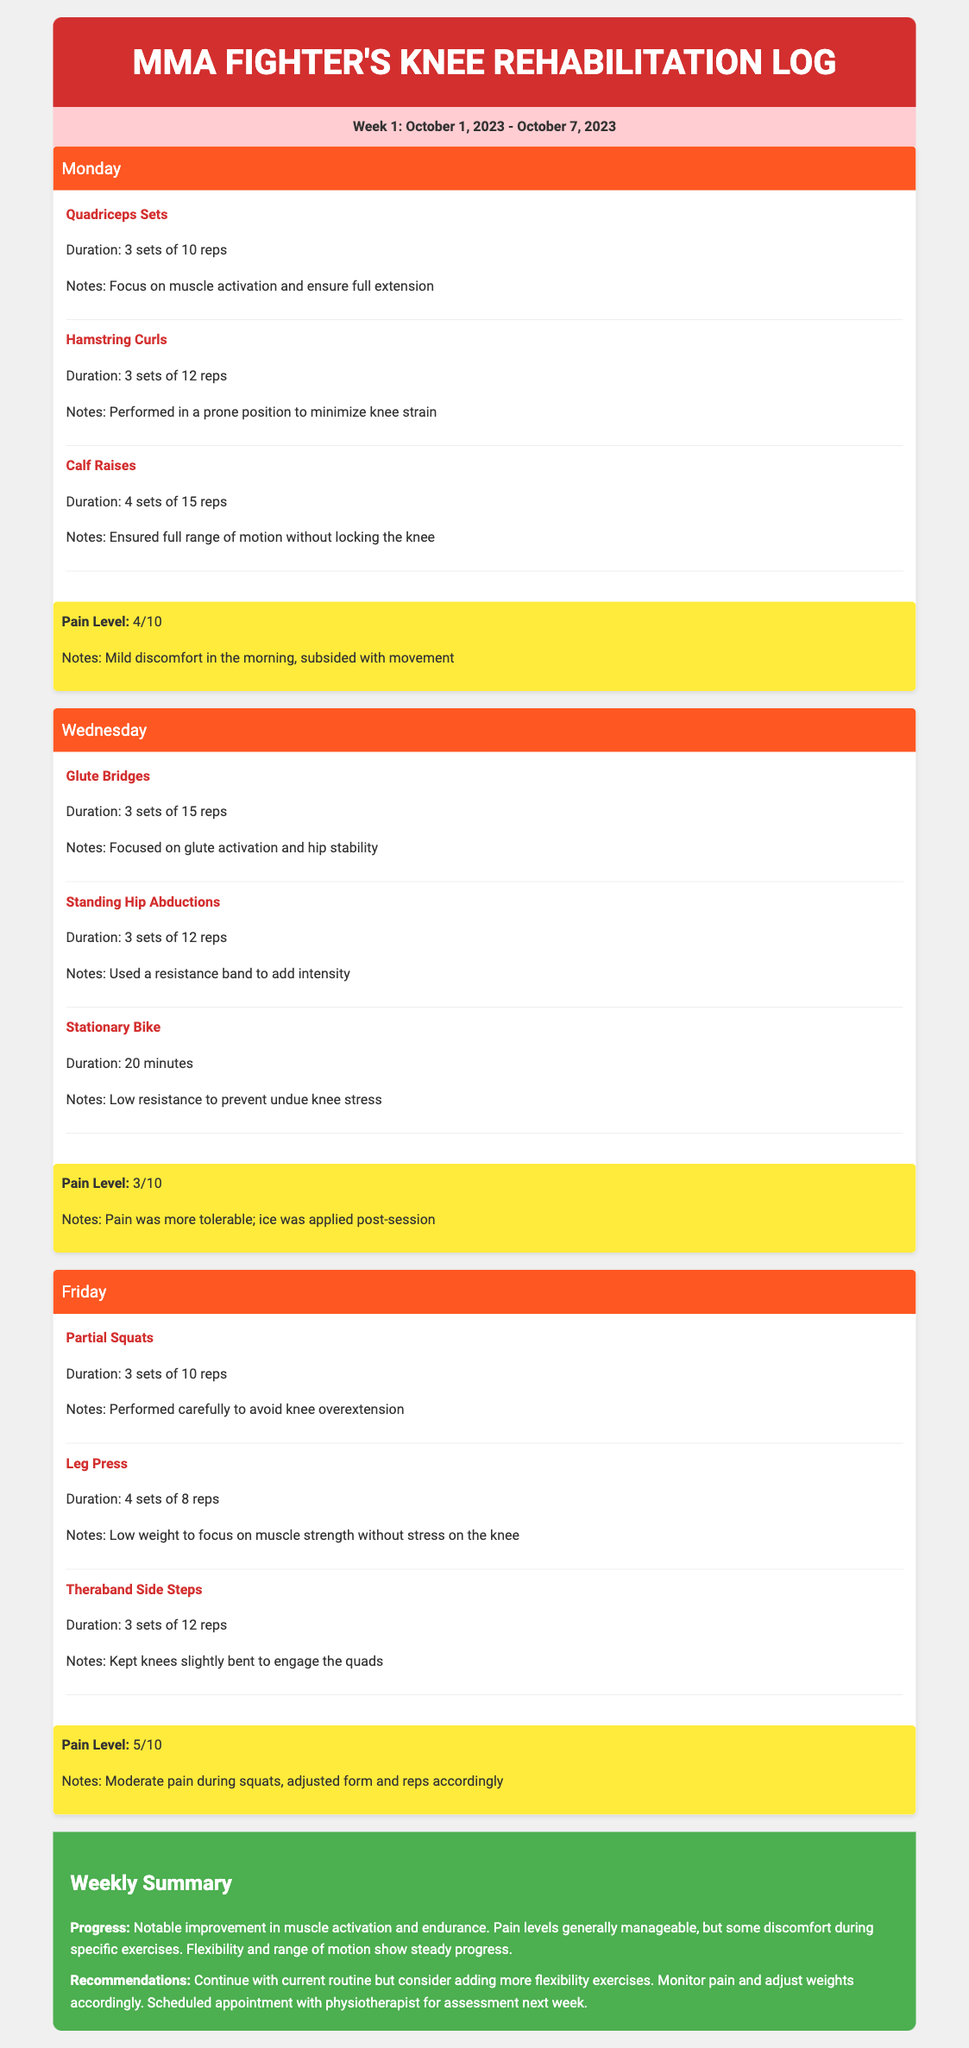What week does the log cover? The week covered in the log is from October 1, 2023, to October 7, 2023.
Answer: Week 1: October 1, 2023 - October 7, 2023 What exercise was performed on Monday? The exercises performed on Monday include Quadriceps Sets, Hamstring Curls, and Calf Raises.
Answer: Quadriceps Sets, Hamstring Curls, Calf Raises What was the pain level recorded after the exercises on Friday? The pain level recorded after the exercises on Friday was 5 out of 10.
Answer: 5/10 How many sets of Glute Bridges were completed on Wednesday? The total sets of Glute Bridges completed on Wednesday were 3 sets.
Answer: 3 sets of 15 reps What does the weekly summary state about progress? The summary indicates notable improvement in muscle activation and endurance with manageable pain levels.
Answer: Notable improvement in muscle activation and endurance What recommendation is given for the next week? The recommendation suggests continuing the current routine but adding more flexibility exercises and monitoring pain.
Answer: Continue with current routine but consider adding more flexibility exercises 